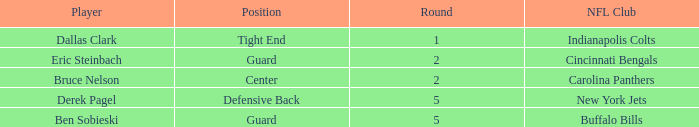What was the latest round that Derek Pagel was selected with a pick higher than 50? 5.0. 